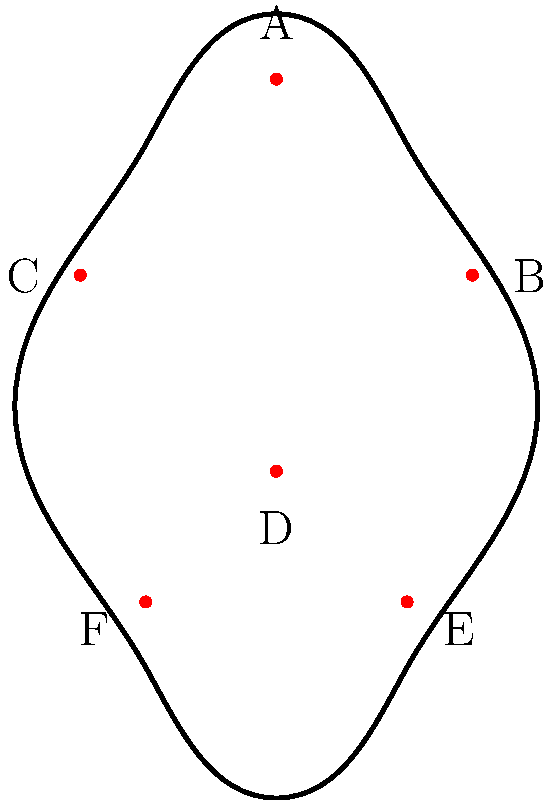Identify the pressure point labeled 'D' on the human body diagram and explain its significance in pain management techniques. To identify and understand the significance of pressure point 'D' in pain management techniques, let's follow these steps:

1. Locate point 'D' on the diagram: It is positioned in the center of the body, slightly below the midpoint.

2. Identify the anatomical location: Point 'D' corresponds to the solar plexus, also known as the celiac plexus.

3. Understand its significance:
   a) The solar plexus is a complex network of nerves located in the upper abdomen.
   b) It plays a crucial role in the functioning of several abdominal organs.
   c) Stimulating this point can help alleviate various types of pain and discomfort.

4. Pain management applications:
   a) Relieving abdominal pain and discomfort
   b) Reducing anxiety and stress
   c) Alleviating nausea and digestive issues
   d) Improving breathing and relaxation

5. Technique for stimulation:
   a) Apply gentle, steady pressure using the fingertips
   b) Maintain pressure for 1-3 minutes while taking deep breaths
   c) Release pressure gradually

6. Precautions:
   a) Avoid applying excessive pressure, as it may cause discomfort
   b) Use caution in patients with abdominal conditions or recent surgeries
   c) Always assess the patient's comfort level during the technique

Understanding and properly stimulating the solar plexus pressure point can be an effective non-pharmacological approach to pain management and stress relief in nursing practice.
Answer: Solar plexus (celiac plexus) 